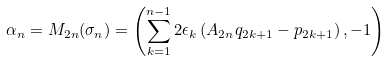<formula> <loc_0><loc_0><loc_500><loc_500>\alpha _ { n } = M _ { 2 n } ( \sigma _ { n } ) = \left ( \sum _ { k = 1 } ^ { n - 1 } 2 \epsilon _ { k } \left ( A _ { 2 n } q _ { 2 k + 1 } - p _ { 2 k + 1 } \right ) , - 1 \right )</formula> 